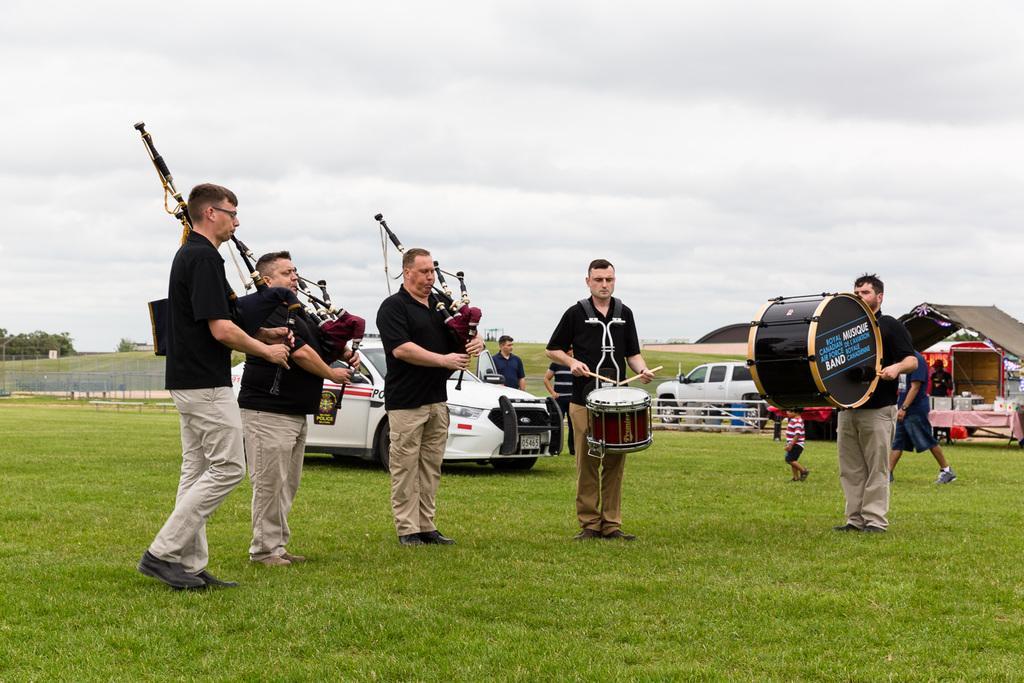How would you summarize this image in a sentence or two? In this Image I see 5 men who are holding their musical instruments and they're on the grass. In the background I see 2 cars, few people and the sky and I can also see trees over here. 